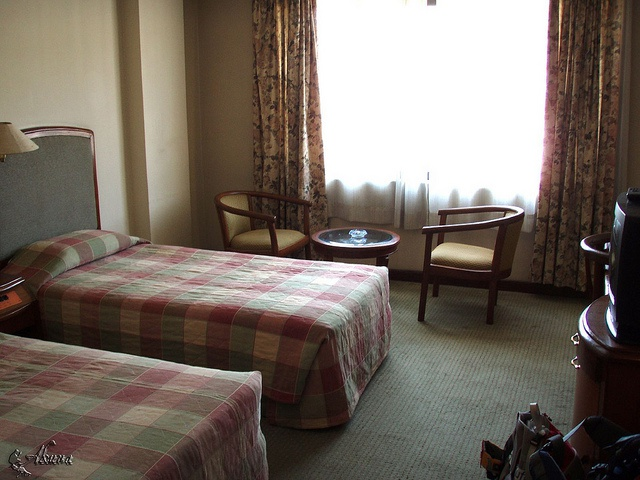Describe the objects in this image and their specific colors. I can see bed in gray, black, darkgray, and maroon tones, bed in gray, black, and maroon tones, chair in gray, black, and maroon tones, chair in gray, black, and maroon tones, and tv in gray, black, and white tones in this image. 